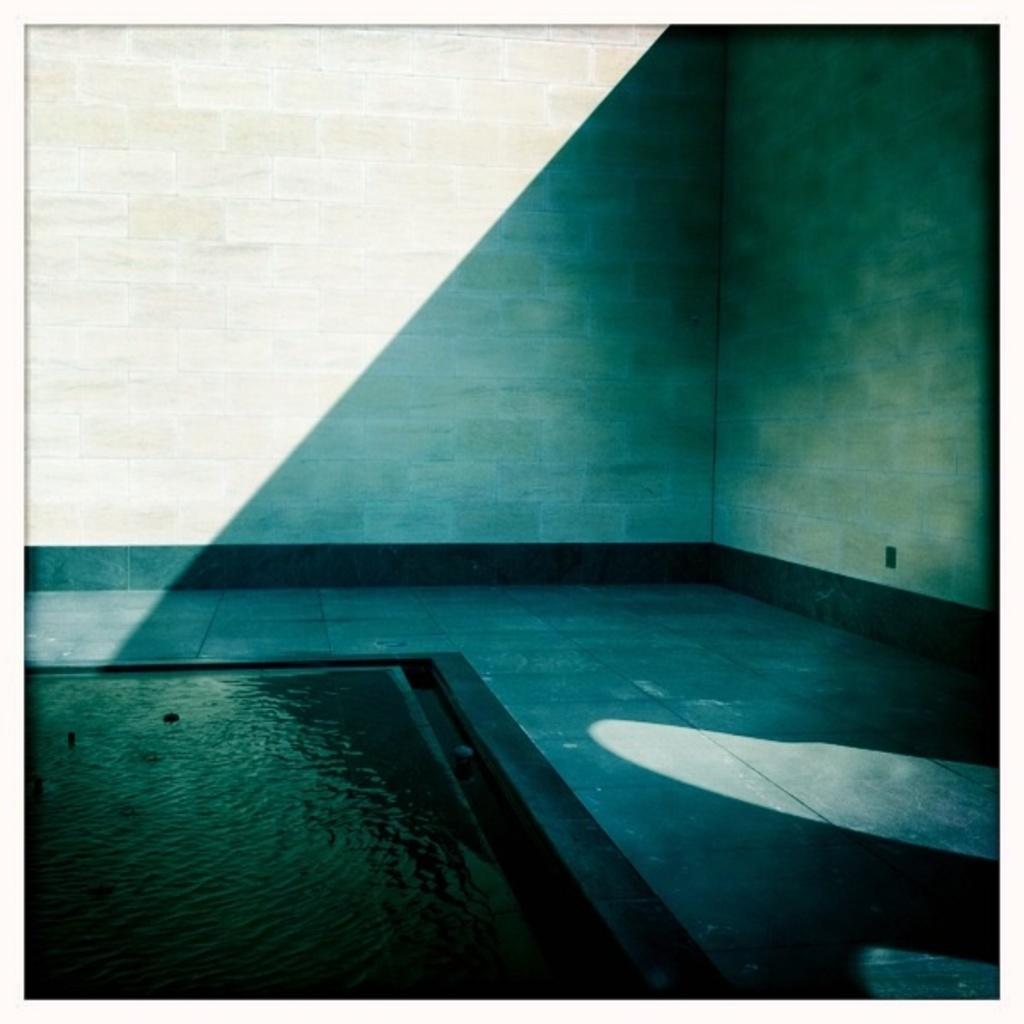In one or two sentences, can you explain what this image depicts? In this picture we can see water, floor and in the background we can see wall. 